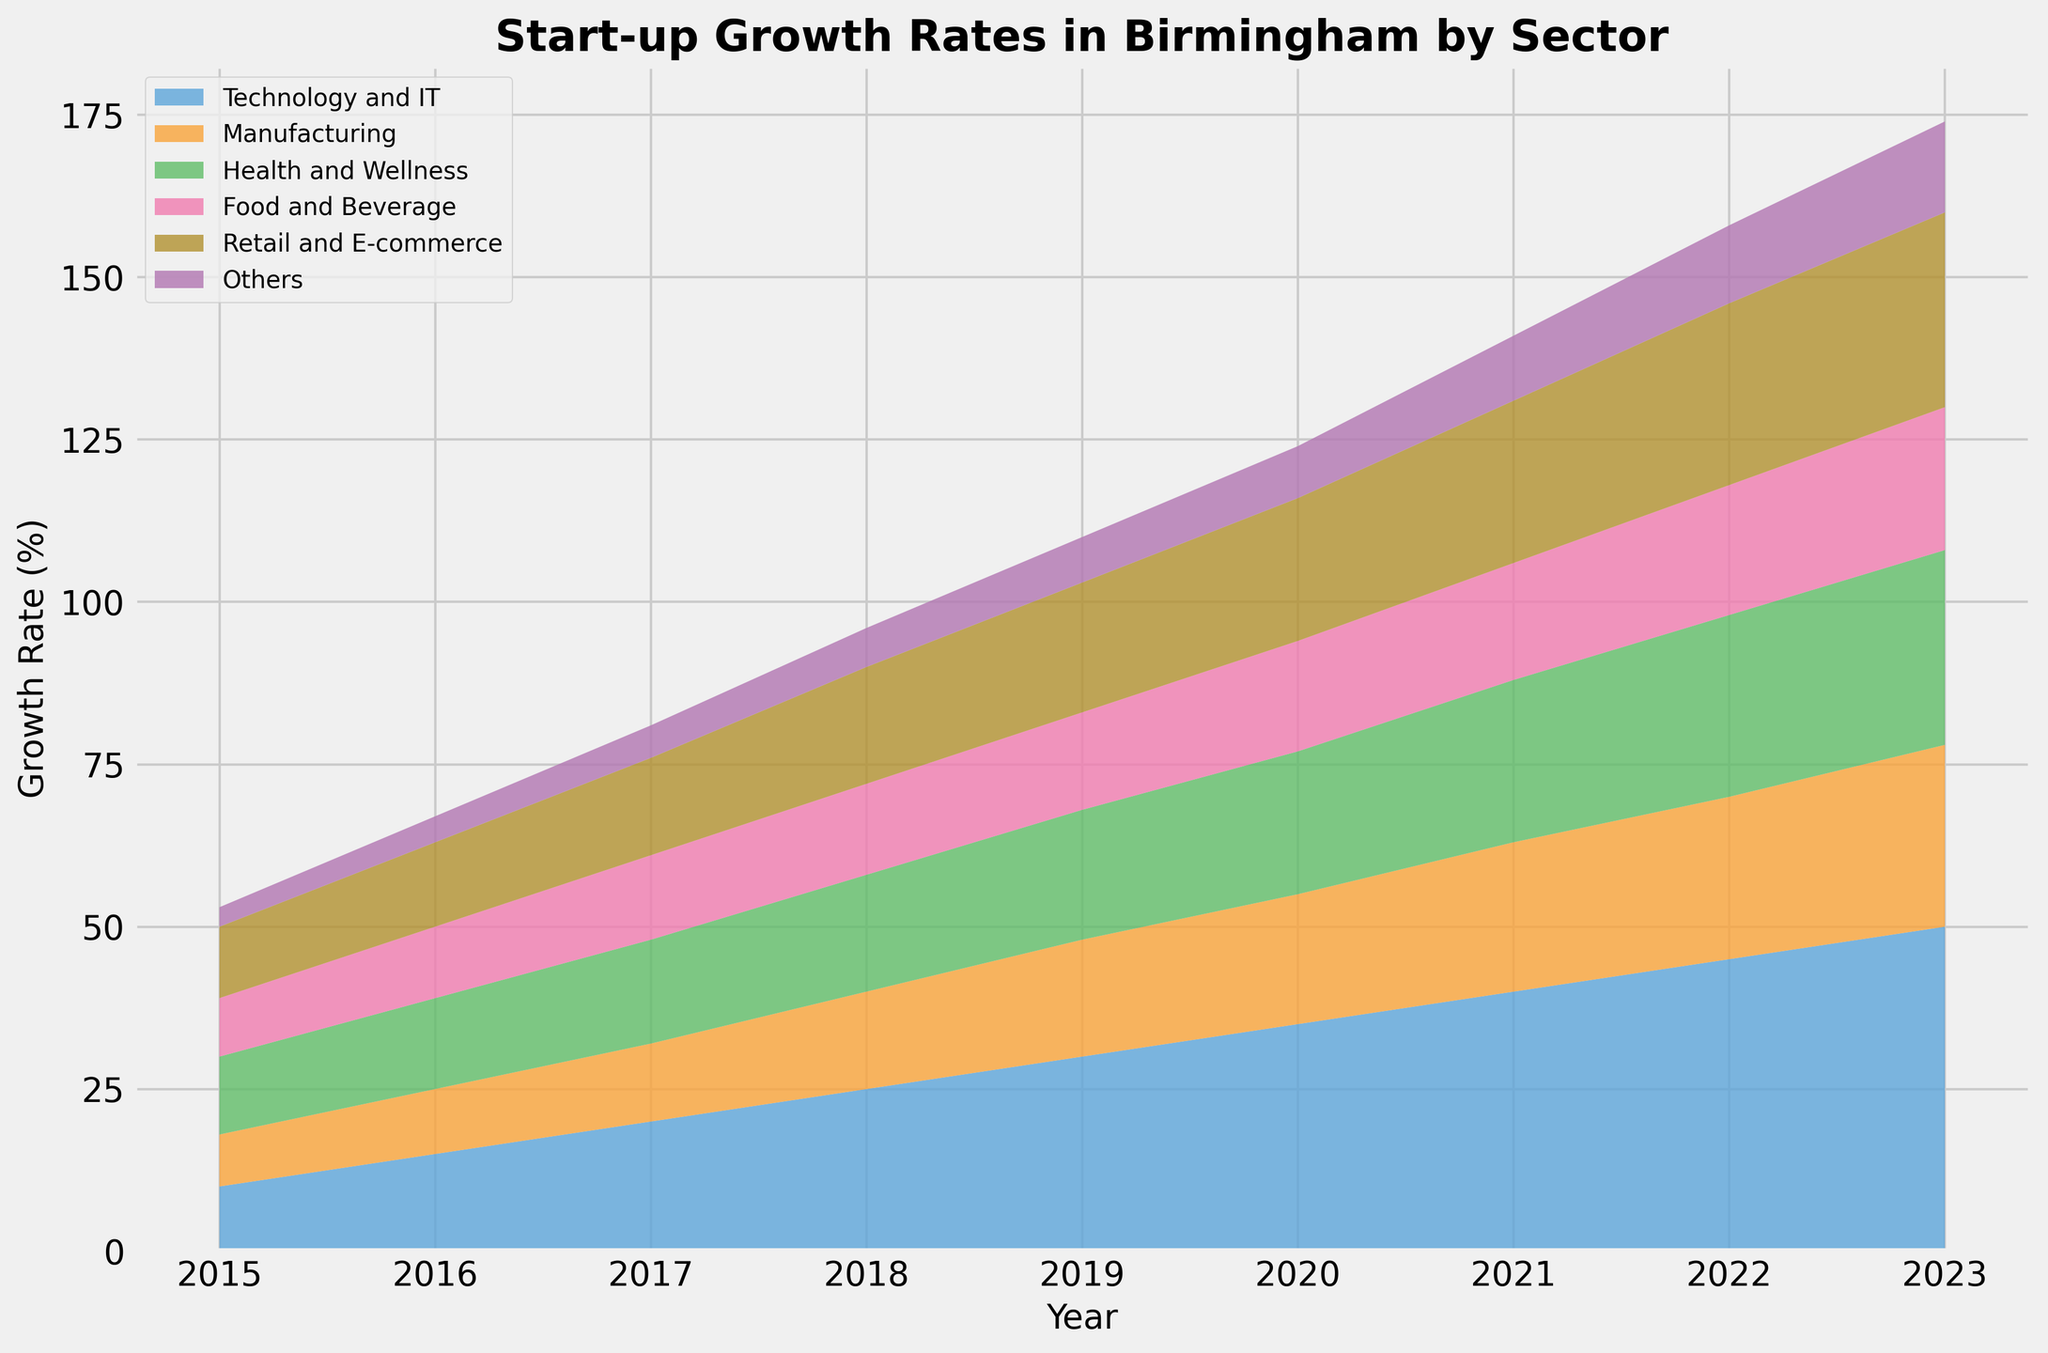What is the growth rate for the Technology and IT sector in 2020? Look for the year 2020 on the x-axis and find the corresponding area segment for Technology and IT. The stackplot's legend indicates that Technology and IT is represented by a specific color.
Answer: 35% Which sector has the highest growth rate in 2023? Compare the segments on the stackplot for the year 2023. The tallest segment represents the sector with the highest growth rate.
Answer: Technology and IT By how much did the growth rate for the Health and Wellness sector increase from 2015 to 2023? Locate the sizes for the Health and Wellness sector in 2015 and 2023 and subtract the 2015 value from the 2023 value. Health and Wellness in 2015 is 12%, and in 2023 it is 30%. So, the increase is 30 - 12.
Answer: 18% What is the combined growth rate for the Manufacturing and Food and Beverage sectors in 2019? Find the values for both Manufacturing and Food and Beverage sectors in 2019. Add them up. Manufacturing is 18% and Food and Beverage is 15%. So, the combined growth rate is 18 + 15.
Answer: 33% Which sector has the most consistent growth rate over the years? Observe the area chart for sectors with relatively uniform and gradual changes year by year, compare it across the years.
Answer: Technology and IT In which year did the Retail and E-commerce sector have a growth rate of 22%? Scan through the years and find the year where the Retail and E-commerce sector reaches 22%. For Retail and E-commerce, the label will guide you to the right segment and year combination.
Answer: 2020 How does the growth rate of the Health and Wellness sector in 2022 compare to the Food and Beverage sector in the same year? Look at the sizes of both Health and Wellness and Food and Beverage in 2022 and compare their values. Health and Wellness is 28%, and Food and Beverage is 20%.
Answer: Health and Wellness is higher What is the average annual growth rate for the ‘Others’ sector over the given period? Sum up the growth rates of ‘Others’ sector from 2015 to 2023 then divide by the number of years (2015-2023 is 9 years). So, (3 + 4 + 5 + 6  + 7 + 8 + 10 + 12 + 14)/9.
Answer: ~7.67% What is the difference in growth rates between the Retail and E-commerce sector and the Health and Wellness sector in 2023? Subtract the growth rate of Health and Wellness from Retail and E-commerce for 2023. Retail and E-commerce is 30%, and Health and Wellness is 30%.
Answer: 0 